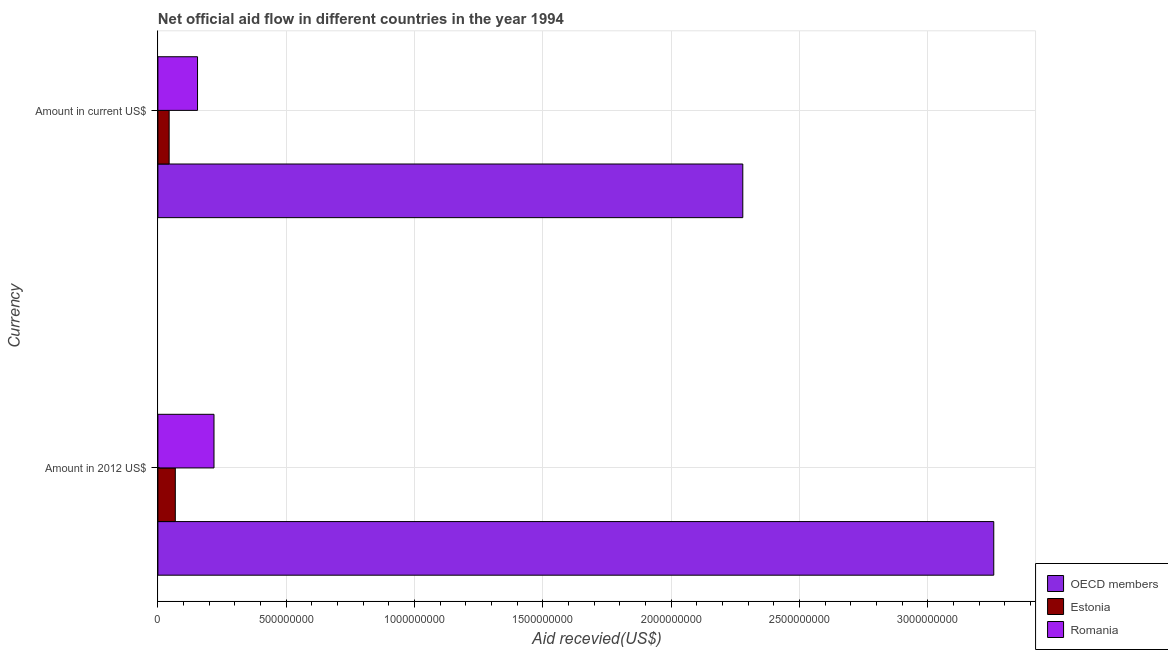How many different coloured bars are there?
Make the answer very short. 3. How many groups of bars are there?
Your answer should be very brief. 2. Are the number of bars on each tick of the Y-axis equal?
Provide a short and direct response. Yes. What is the label of the 2nd group of bars from the top?
Offer a very short reply. Amount in 2012 US$. What is the amount of aid received(expressed in 2012 us$) in Estonia?
Keep it short and to the point. 6.78e+07. Across all countries, what is the maximum amount of aid received(expressed in 2012 us$)?
Offer a very short reply. 3.26e+09. Across all countries, what is the minimum amount of aid received(expressed in us$)?
Your answer should be compact. 4.38e+07. In which country was the amount of aid received(expressed in us$) minimum?
Keep it short and to the point. Estonia. What is the total amount of aid received(expressed in 2012 us$) in the graph?
Your answer should be very brief. 3.54e+09. What is the difference between the amount of aid received(expressed in us$) in Estonia and that in Romania?
Ensure brevity in your answer.  -1.11e+08. What is the difference between the amount of aid received(expressed in us$) in Romania and the amount of aid received(expressed in 2012 us$) in OECD members?
Your answer should be very brief. -3.10e+09. What is the average amount of aid received(expressed in us$) per country?
Keep it short and to the point. 8.26e+08. What is the difference between the amount of aid received(expressed in 2012 us$) and amount of aid received(expressed in us$) in OECD members?
Provide a short and direct response. 9.78e+08. What is the ratio of the amount of aid received(expressed in 2012 us$) in Romania to that in OECD members?
Keep it short and to the point. 0.07. Is the amount of aid received(expressed in 2012 us$) in Estonia less than that in Romania?
Give a very brief answer. Yes. What does the 2nd bar from the top in Amount in 2012 US$ represents?
Your answer should be compact. Estonia. What does the 3rd bar from the bottom in Amount in 2012 US$ represents?
Offer a terse response. Romania. How many bars are there?
Offer a terse response. 6. Are all the bars in the graph horizontal?
Your response must be concise. Yes. How many countries are there in the graph?
Ensure brevity in your answer.  3. What is the difference between two consecutive major ticks on the X-axis?
Offer a terse response. 5.00e+08. Are the values on the major ticks of X-axis written in scientific E-notation?
Offer a very short reply. No. Does the graph contain any zero values?
Keep it short and to the point. No. Does the graph contain grids?
Offer a very short reply. Yes. Where does the legend appear in the graph?
Your response must be concise. Bottom right. How many legend labels are there?
Offer a terse response. 3. What is the title of the graph?
Provide a short and direct response. Net official aid flow in different countries in the year 1994. What is the label or title of the X-axis?
Your answer should be compact. Aid recevied(US$). What is the label or title of the Y-axis?
Keep it short and to the point. Currency. What is the Aid recevied(US$) in OECD members in Amount in 2012 US$?
Provide a short and direct response. 3.26e+09. What is the Aid recevied(US$) of Estonia in Amount in 2012 US$?
Offer a terse response. 6.78e+07. What is the Aid recevied(US$) of Romania in Amount in 2012 US$?
Give a very brief answer. 2.19e+08. What is the Aid recevied(US$) of OECD members in Amount in current US$?
Provide a short and direct response. 2.28e+09. What is the Aid recevied(US$) in Estonia in Amount in current US$?
Provide a short and direct response. 4.38e+07. What is the Aid recevied(US$) of Romania in Amount in current US$?
Your answer should be compact. 1.54e+08. Across all Currency, what is the maximum Aid recevied(US$) in OECD members?
Offer a terse response. 3.26e+09. Across all Currency, what is the maximum Aid recevied(US$) in Estonia?
Your response must be concise. 6.78e+07. Across all Currency, what is the maximum Aid recevied(US$) of Romania?
Make the answer very short. 2.19e+08. Across all Currency, what is the minimum Aid recevied(US$) of OECD members?
Your response must be concise. 2.28e+09. Across all Currency, what is the minimum Aid recevied(US$) in Estonia?
Your answer should be compact. 4.38e+07. Across all Currency, what is the minimum Aid recevied(US$) of Romania?
Provide a succinct answer. 1.54e+08. What is the total Aid recevied(US$) of OECD members in the graph?
Keep it short and to the point. 5.54e+09. What is the total Aid recevied(US$) in Estonia in the graph?
Keep it short and to the point. 1.12e+08. What is the total Aid recevied(US$) in Romania in the graph?
Ensure brevity in your answer.  3.73e+08. What is the difference between the Aid recevied(US$) in OECD members in Amount in 2012 US$ and that in Amount in current US$?
Make the answer very short. 9.78e+08. What is the difference between the Aid recevied(US$) in Estonia in Amount in 2012 US$ and that in Amount in current US$?
Provide a short and direct response. 2.40e+07. What is the difference between the Aid recevied(US$) in Romania in Amount in 2012 US$ and that in Amount in current US$?
Provide a succinct answer. 6.42e+07. What is the difference between the Aid recevied(US$) of OECD members in Amount in 2012 US$ and the Aid recevied(US$) of Estonia in Amount in current US$?
Provide a succinct answer. 3.21e+09. What is the difference between the Aid recevied(US$) in OECD members in Amount in 2012 US$ and the Aid recevied(US$) in Romania in Amount in current US$?
Your answer should be compact. 3.10e+09. What is the difference between the Aid recevied(US$) of Estonia in Amount in 2012 US$ and the Aid recevied(US$) of Romania in Amount in current US$?
Provide a short and direct response. -8.66e+07. What is the average Aid recevied(US$) of OECD members per Currency?
Provide a short and direct response. 2.77e+09. What is the average Aid recevied(US$) of Estonia per Currency?
Offer a very short reply. 5.58e+07. What is the average Aid recevied(US$) of Romania per Currency?
Offer a terse response. 1.86e+08. What is the difference between the Aid recevied(US$) in OECD members and Aid recevied(US$) in Estonia in Amount in 2012 US$?
Your response must be concise. 3.19e+09. What is the difference between the Aid recevied(US$) in OECD members and Aid recevied(US$) in Romania in Amount in 2012 US$?
Keep it short and to the point. 3.04e+09. What is the difference between the Aid recevied(US$) of Estonia and Aid recevied(US$) of Romania in Amount in 2012 US$?
Keep it short and to the point. -1.51e+08. What is the difference between the Aid recevied(US$) of OECD members and Aid recevied(US$) of Estonia in Amount in current US$?
Your answer should be very brief. 2.24e+09. What is the difference between the Aid recevied(US$) of OECD members and Aid recevied(US$) of Romania in Amount in current US$?
Provide a succinct answer. 2.12e+09. What is the difference between the Aid recevied(US$) in Estonia and Aid recevied(US$) in Romania in Amount in current US$?
Keep it short and to the point. -1.11e+08. What is the ratio of the Aid recevied(US$) in OECD members in Amount in 2012 US$ to that in Amount in current US$?
Your response must be concise. 1.43. What is the ratio of the Aid recevied(US$) in Estonia in Amount in 2012 US$ to that in Amount in current US$?
Provide a short and direct response. 1.55. What is the ratio of the Aid recevied(US$) in Romania in Amount in 2012 US$ to that in Amount in current US$?
Your answer should be very brief. 1.42. What is the difference between the highest and the second highest Aid recevied(US$) in OECD members?
Offer a terse response. 9.78e+08. What is the difference between the highest and the second highest Aid recevied(US$) in Estonia?
Provide a succinct answer. 2.40e+07. What is the difference between the highest and the second highest Aid recevied(US$) of Romania?
Offer a very short reply. 6.42e+07. What is the difference between the highest and the lowest Aid recevied(US$) in OECD members?
Provide a short and direct response. 9.78e+08. What is the difference between the highest and the lowest Aid recevied(US$) in Estonia?
Provide a short and direct response. 2.40e+07. What is the difference between the highest and the lowest Aid recevied(US$) of Romania?
Make the answer very short. 6.42e+07. 